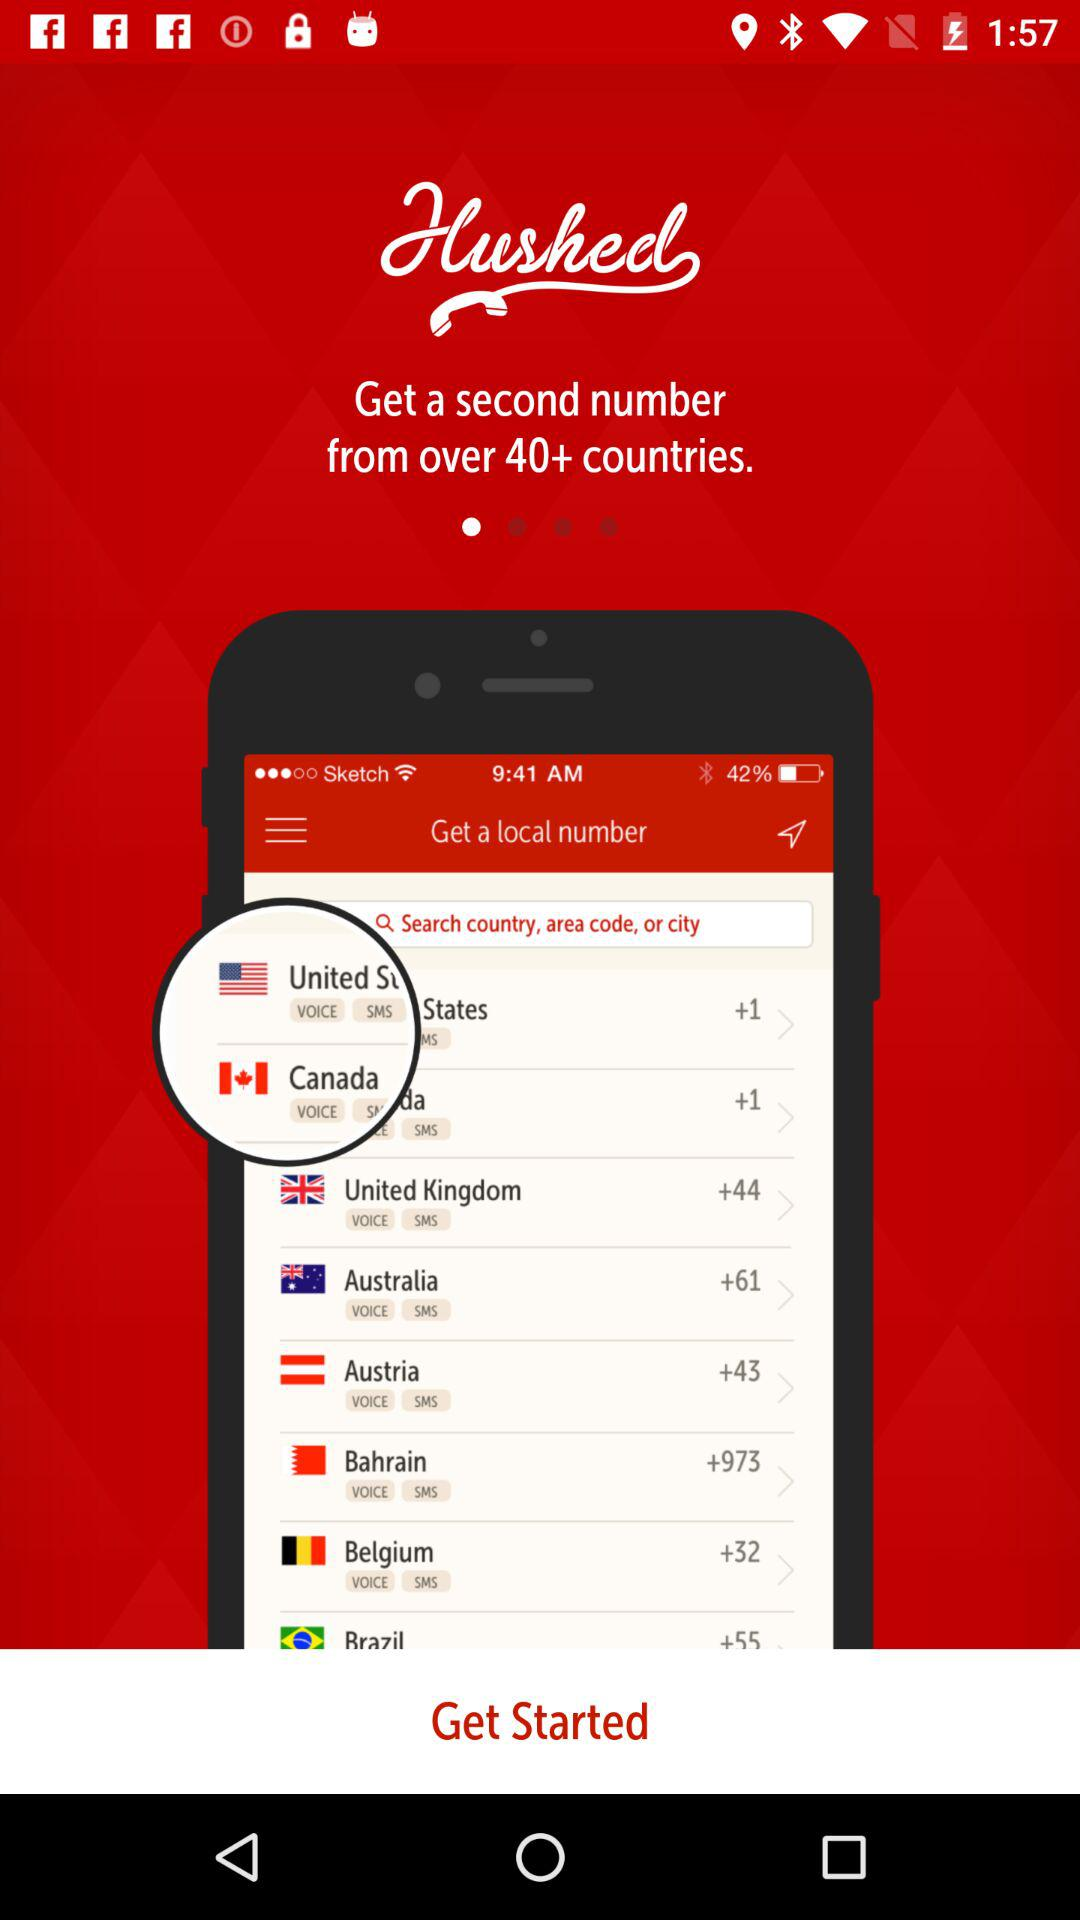From how many countries can a user get a second number? A user can get a second number from more than 40 countries. 